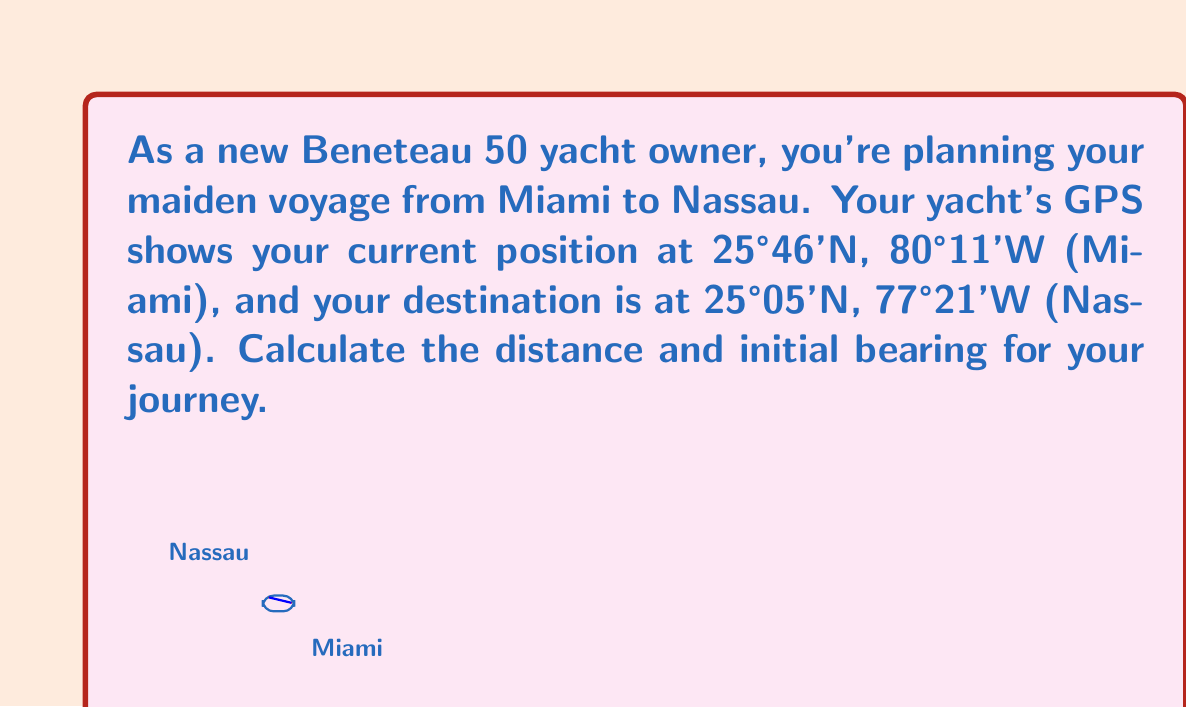Help me with this question. To solve this problem, we'll use the haversine formula for distance and the initial bearing formula. Let's break it down step-by-step:

1) Convert coordinates to radians:
   $$\begin{align*}
   \text{lat}_1 &= 25.767° \times \frac{\pi}{180} = 0.4496 \text{ rad}\\
   \text{lon}_1 &= -80.183° \times \frac{\pi}{180} = -1.3994 \text{ rad}\\
   \text{lat}_2 &= 25.083° \times \frac{\pi}{180} = 0.4377 \text{ rad}\\
   \text{lon}_2 &= -77.350° \times \frac{\pi}{180} = -1.3498 \text{ rad}
   \end{align*}$$

2) Calculate the difference in longitude:
   $$\Delta\text{lon} = \text{lon}_2 - \text{lon}_1 = 0.0496 \text{ rad}$$

3) Use the haversine formula to calculate the central angle $\theta$:
   $$\begin{align*}
   a &= \sin^2(\frac{\Delta\text{lat}}{2}) + \cos(\text{lat}_1) \cos(\text{lat}_2) \sin^2(\frac{\Delta\text{lon}}{2})\\
   &= \sin^2(-0.00595) + \cos(0.4496) \cos(0.4377) \sin^2(0.0248)\\
   &= 0.000410
   \end{align*}$$
   
   $$\theta = 2 \arcsin(\sqrt{a}) = 0.0405 \text{ rad}$$

4) Calculate the distance:
   $$d = R \theta = 6371 \times 0.0405 = 258.0 \text{ km} = 139.3 \text{ nautical miles}$$

5) Calculate the initial bearing:
   $$\begin{align*}
   y &= \sin(\Delta\text{lon}) \cos(\text{lat}_2) = 0.0480\\
   x &= \cos(\text{lat}_1) \sin(\text{lat}_2) - \sin(\text{lat}_1) \cos(\text{lat}_2) \cos(\Delta\text{lon}) = -0.0119\\
   \text{bearing} &= \arctan2(y, x) = 1.8151 \text{ rad} = 104.0°
   \end{align*}$$

Therefore, the distance is approximately 139.3 nautical miles, and the initial bearing is 104.0° (east-southeast).
Answer: 139.3 NM, 104.0° 